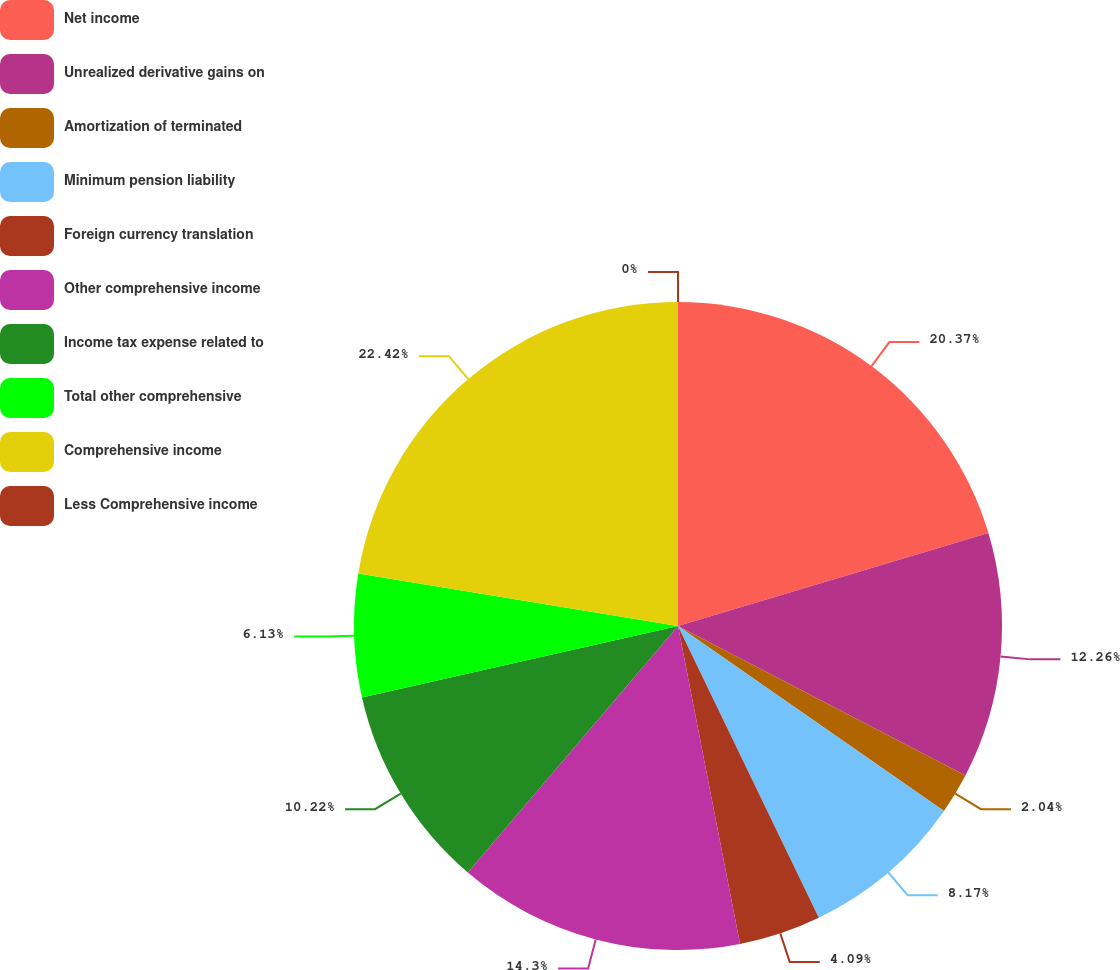Convert chart. <chart><loc_0><loc_0><loc_500><loc_500><pie_chart><fcel>Net income<fcel>Unrealized derivative gains on<fcel>Amortization of terminated<fcel>Minimum pension liability<fcel>Foreign currency translation<fcel>Other comprehensive income<fcel>Income tax expense related to<fcel>Total other comprehensive<fcel>Comprehensive income<fcel>Less Comprehensive income<nl><fcel>20.37%<fcel>12.26%<fcel>2.04%<fcel>8.17%<fcel>4.09%<fcel>14.3%<fcel>10.22%<fcel>6.13%<fcel>22.41%<fcel>0.0%<nl></chart> 